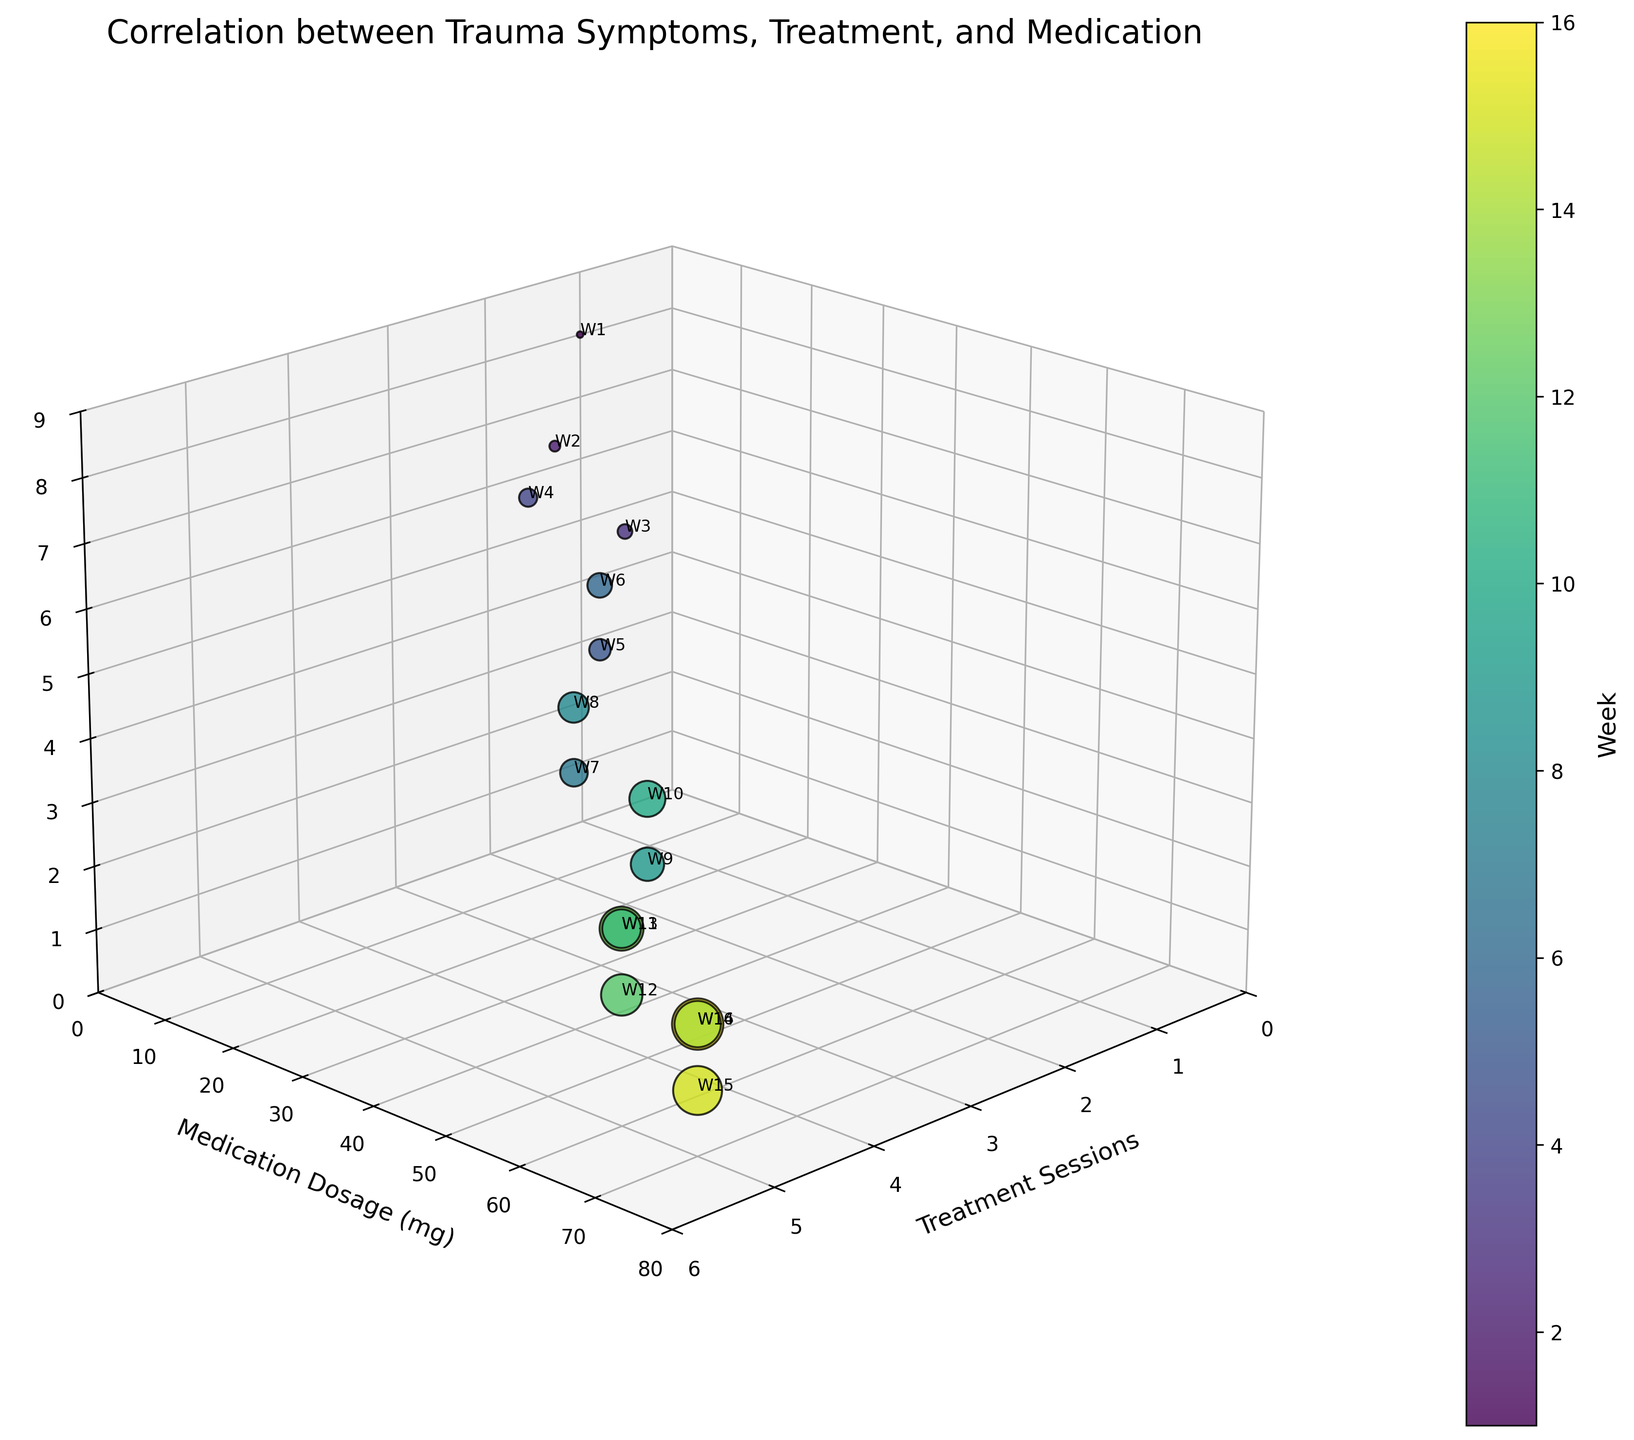What is the title of the figure? The title is written at the top of the graph and typically summarizes the contents and intent of the visualization.
Answer: Correlation between Trauma Symptoms, Treatment, and Medication What are the labels on the axes? The labels on the axes describe what each axis of the 3D plot represents and can be found along the respective axes.
Answer: Treatment Sessions, Medication Dosage (mg), Symptom Severity How many data points are there in the figure? The number of data points can be determined by counting the individual bubbles present in the 3D bubble chart.
Answer: 16 Which week has the largest bubble in the figure? The size of the bubble is proportional to the week number, and the largest bubble would therefore correspond to the highest week number.
Answer: Week 16 Which week has the highest Symptom Severity? To identify this, one can look for the highest z-value (Symptom Severity) on the plot and find the corresponding week number usually labeled next to the bubble.
Answer: Week 1 How does the Symptom Severity change from Week 1 to Week 16? Observe how the z-values (Symptom Severity) associated with weeks 1 and 16 change. Week 1 has a Symptom Severity of 8, while Week 16 has a Symptom Severity of 2.
Answer: Decreases Which week had the highest Medication Dosage (mg) and what was the Symptom Severity that week? Look for the highest y-value representing Medication Dosage and find the corresponding z-value for Symptom Severity next to the same bubble.
Answer: Week 15, Symptom Severity: 1 How are the Treatment Sessions distributed over the weeks? The distribution of Treatment Sessions over the weeks can be determined by observing how the bubbles are positioned along the x-axis.
Answer: Ranges from 1 to 5 and increases over time What is the trend in Medication Dosage over time? By observing the color gradient (representing weeks) and the y-values (Medication Dosage) of the bubbles, one can ascertain that Medication Dosage tends to increase over the weeks.
Answer: Increases over time Which weeks have exactly 4 Treatment Sessions? By focusing on the x-value of 4 on the plot and checking which weeks have bubbles present at this x-value, we find those weeks.
Answer: Weeks 7, 8, 9, 10 